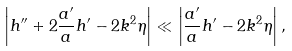<formula> <loc_0><loc_0><loc_500><loc_500>\left | h ^ { \prime \prime } + 2 \frac { a ^ { \prime } } { a } h ^ { \prime } - 2 k ^ { 2 } \eta \right | \ll \left | \frac { a ^ { \prime } } { a } h ^ { \prime } - 2 k ^ { 2 } \eta \right | ,</formula> 